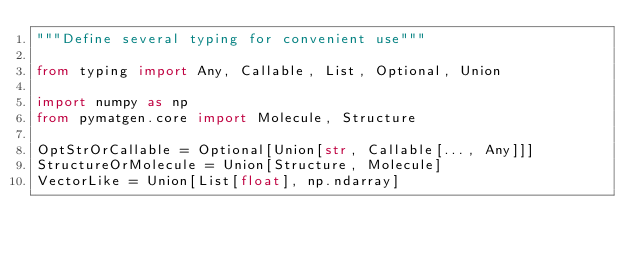Convert code to text. <code><loc_0><loc_0><loc_500><loc_500><_Python_>"""Define several typing for convenient use"""

from typing import Any, Callable, List, Optional, Union

import numpy as np
from pymatgen.core import Molecule, Structure

OptStrOrCallable = Optional[Union[str, Callable[..., Any]]]
StructureOrMolecule = Union[Structure, Molecule]
VectorLike = Union[List[float], np.ndarray]
</code> 